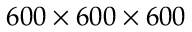<formula> <loc_0><loc_0><loc_500><loc_500>6 0 0 \times 6 0 0 \times 6 0 0</formula> 